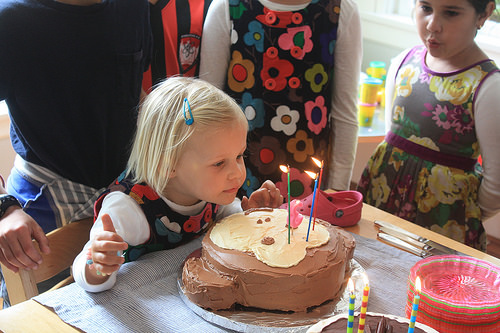<image>
Is there a cake in front of the girl? Yes. The cake is positioned in front of the girl, appearing closer to the camera viewpoint. Where is the kid in relation to the cake? Is it above the cake? No. The kid is not positioned above the cake. The vertical arrangement shows a different relationship. 